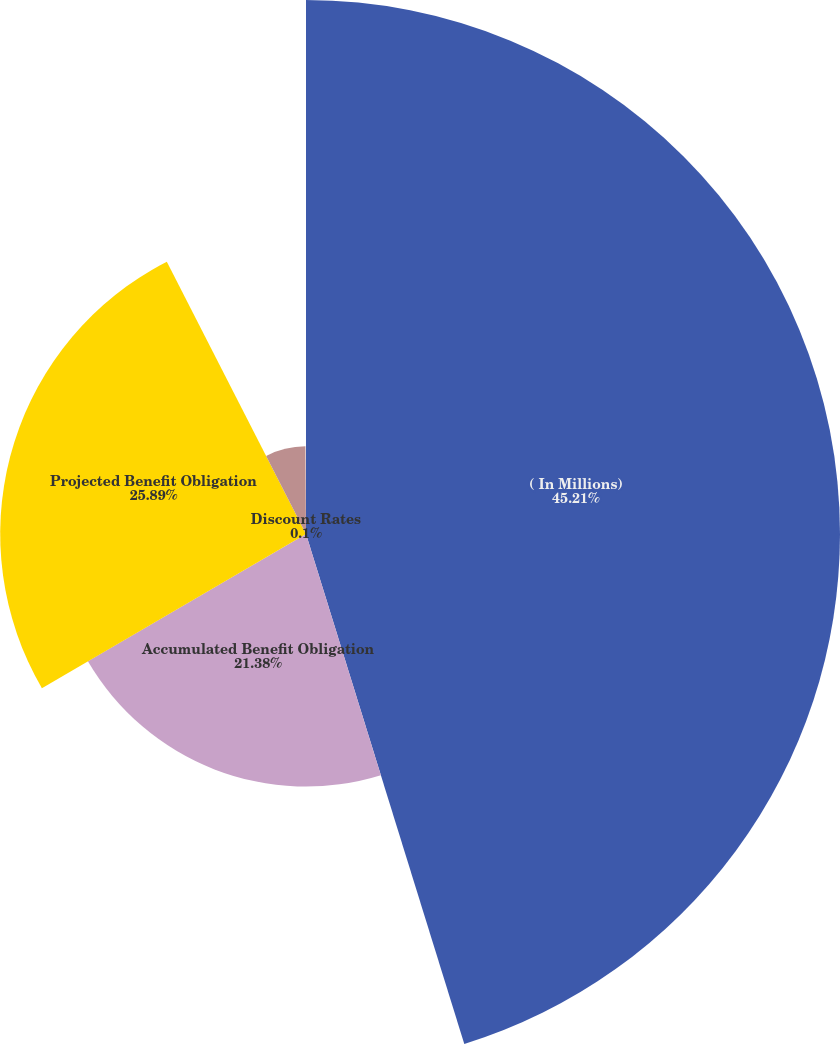Convert chart. <chart><loc_0><loc_0><loc_500><loc_500><pie_chart><fcel>( In Millions)<fcel>Accumulated Benefit Obligation<fcel>Projected Benefit Obligation<fcel>Funded Status at December 31<fcel>Discount Rates<nl><fcel>45.21%<fcel>21.38%<fcel>25.89%<fcel>7.42%<fcel>0.1%<nl></chart> 